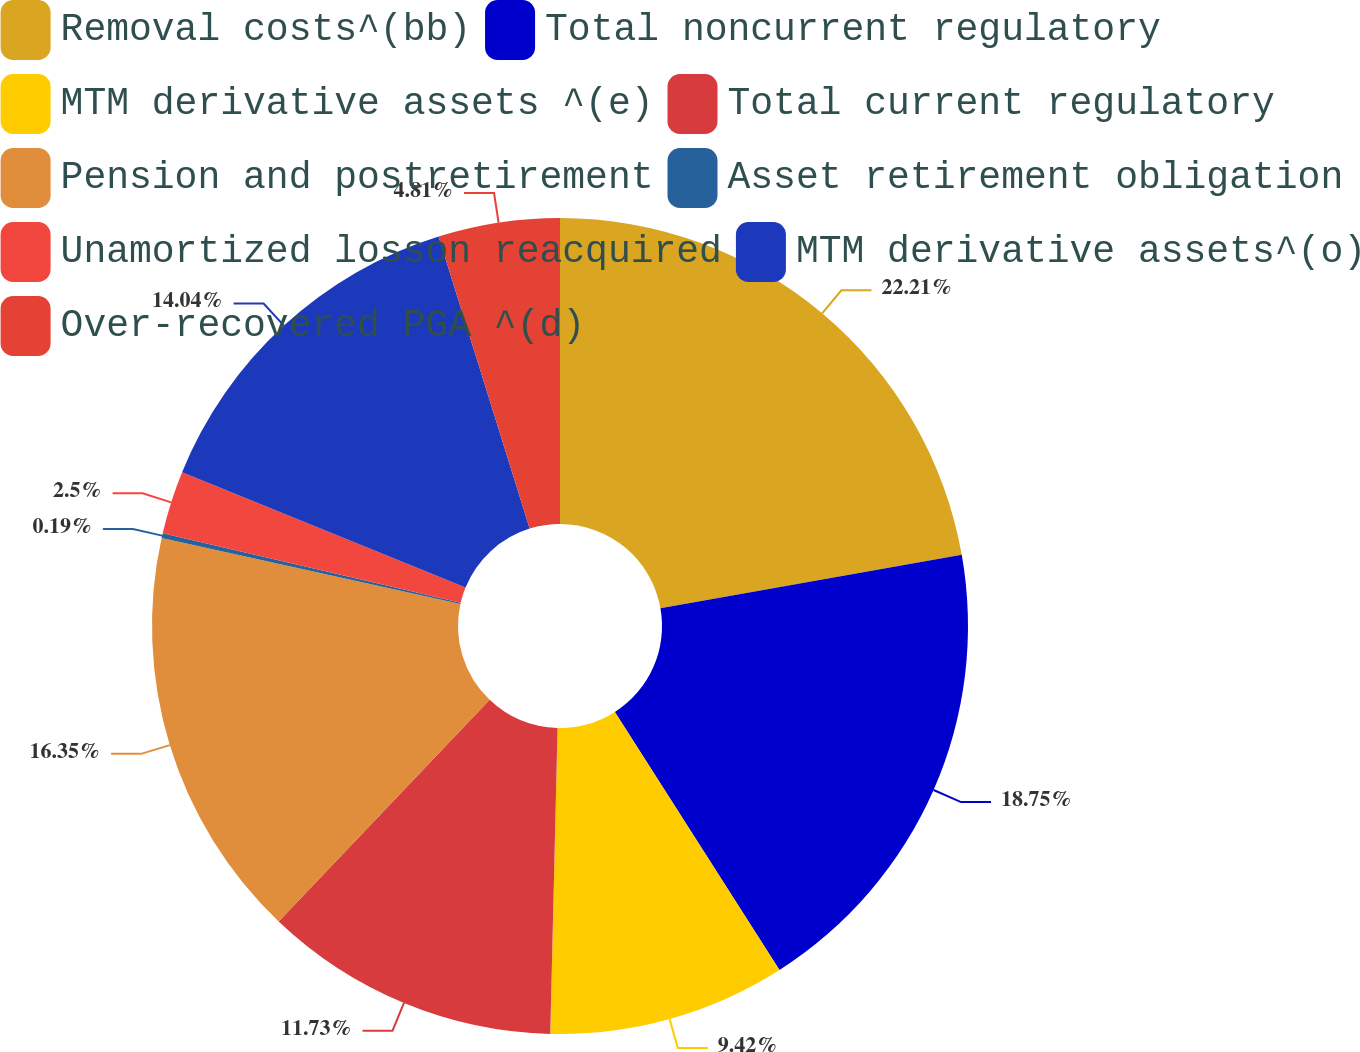Convert chart. <chart><loc_0><loc_0><loc_500><loc_500><pie_chart><fcel>Removal costs^(bb)<fcel>Total noncurrent regulatory<fcel>MTM derivative assets ^(e)<fcel>Total current regulatory<fcel>Pension and postretirement<fcel>Asset retirement obligation<fcel>Unamortized losson reacquired<fcel>MTM derivative assets^(o)<fcel>Over-recovered PGA ^(d)<nl><fcel>22.21%<fcel>18.75%<fcel>9.42%<fcel>11.73%<fcel>16.35%<fcel>0.19%<fcel>2.5%<fcel>14.04%<fcel>4.81%<nl></chart> 